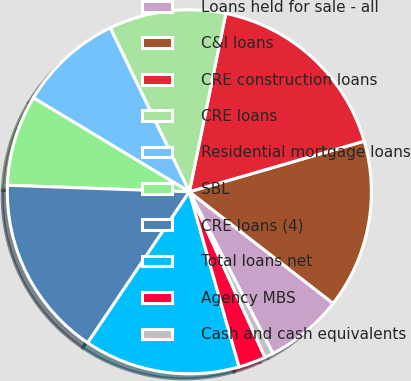Convert chart to OTSL. <chart><loc_0><loc_0><loc_500><loc_500><pie_chart><fcel>Loans held for sale - all<fcel>C&I loans<fcel>CRE construction loans<fcel>CRE loans<fcel>Residential mortgage loans<fcel>SBL<fcel>CRE loans (4)<fcel>Total loans net<fcel>Agency MBS<fcel>Cash and cash equivalents<nl><fcel>6.9%<fcel>14.99%<fcel>17.3%<fcel>10.37%<fcel>9.21%<fcel>8.06%<fcel>16.14%<fcel>13.83%<fcel>2.42%<fcel>0.77%<nl></chart> 